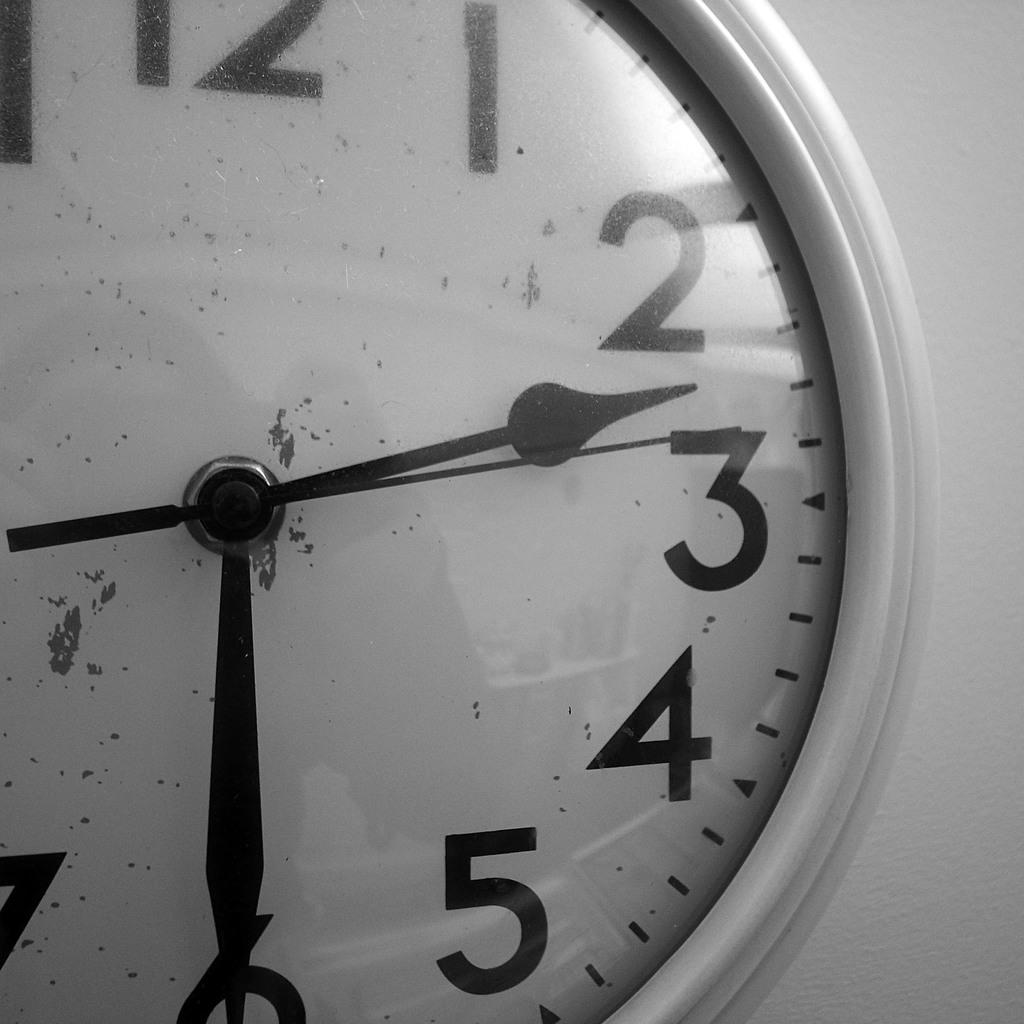<image>
Provide a brief description of the given image. An analog clock is hung on a wall and shows the time to be 2:30. 